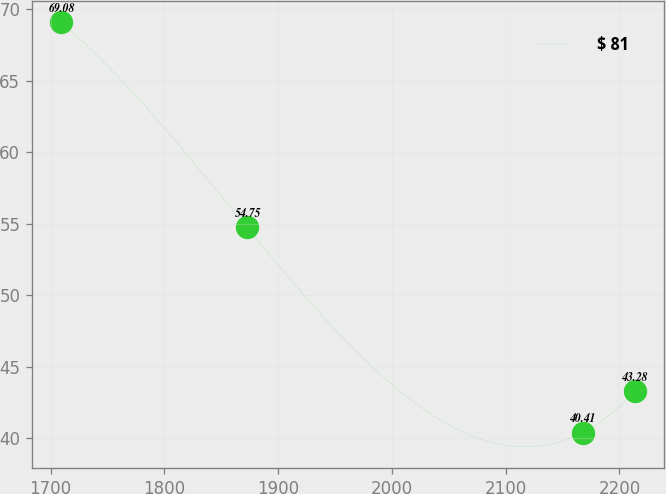<chart> <loc_0><loc_0><loc_500><loc_500><line_chart><ecel><fcel>$ 81<nl><fcel>1708.84<fcel>69.08<nl><fcel>1872.53<fcel>54.75<nl><fcel>2167.62<fcel>40.41<nl><fcel>2213.52<fcel>43.28<nl></chart> 